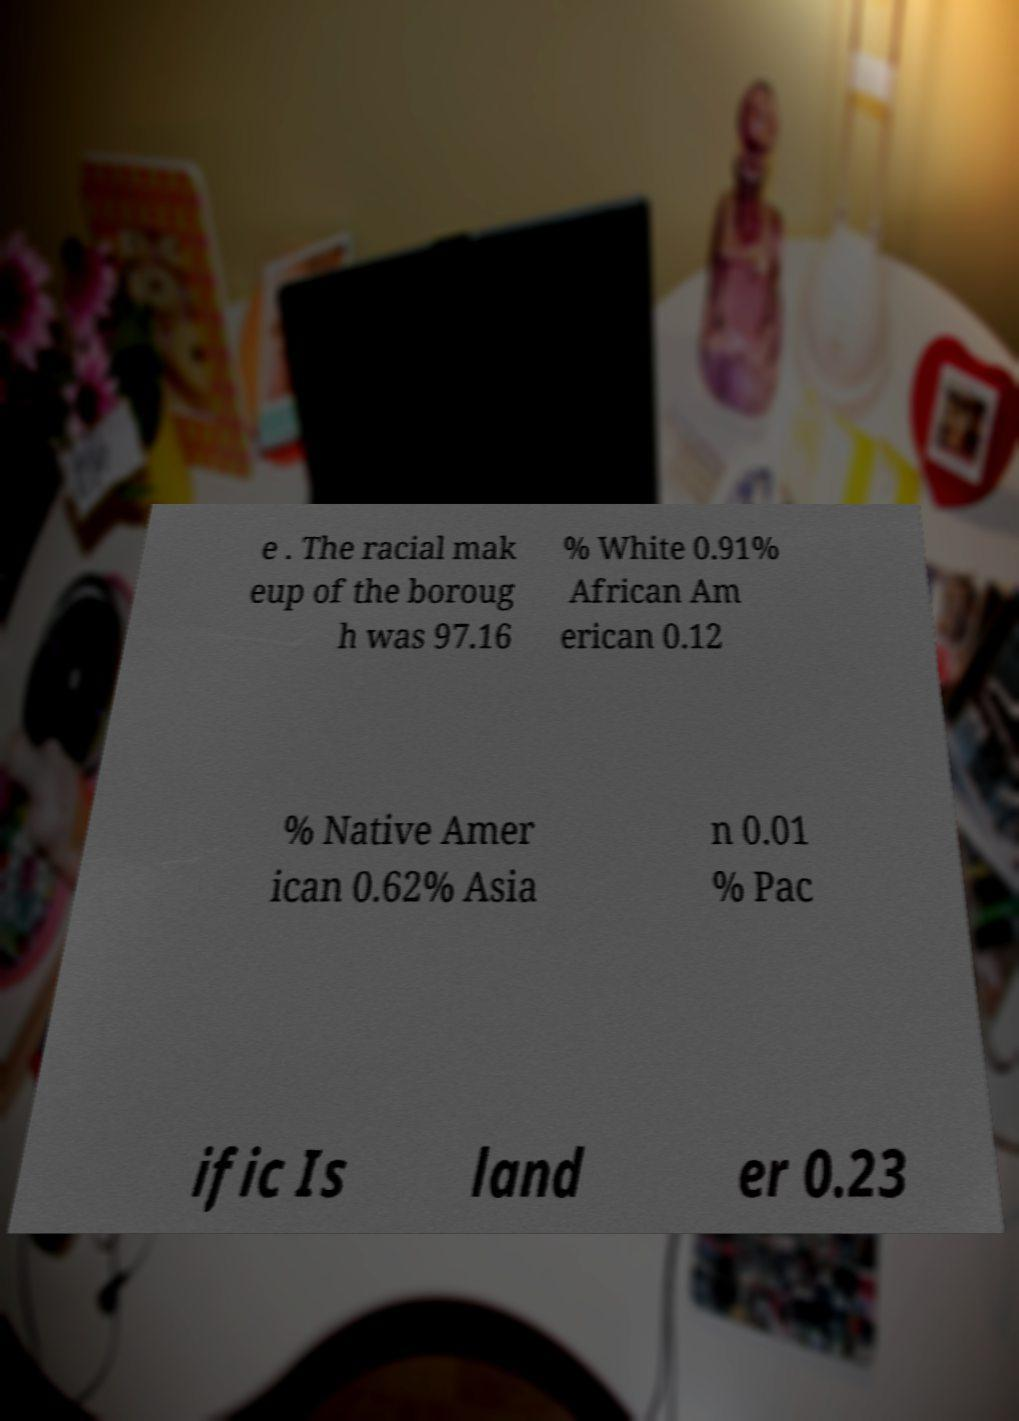Could you extract and type out the text from this image? e . The racial mak eup of the boroug h was 97.16 % White 0.91% African Am erican 0.12 % Native Amer ican 0.62% Asia n 0.01 % Pac ific Is land er 0.23 